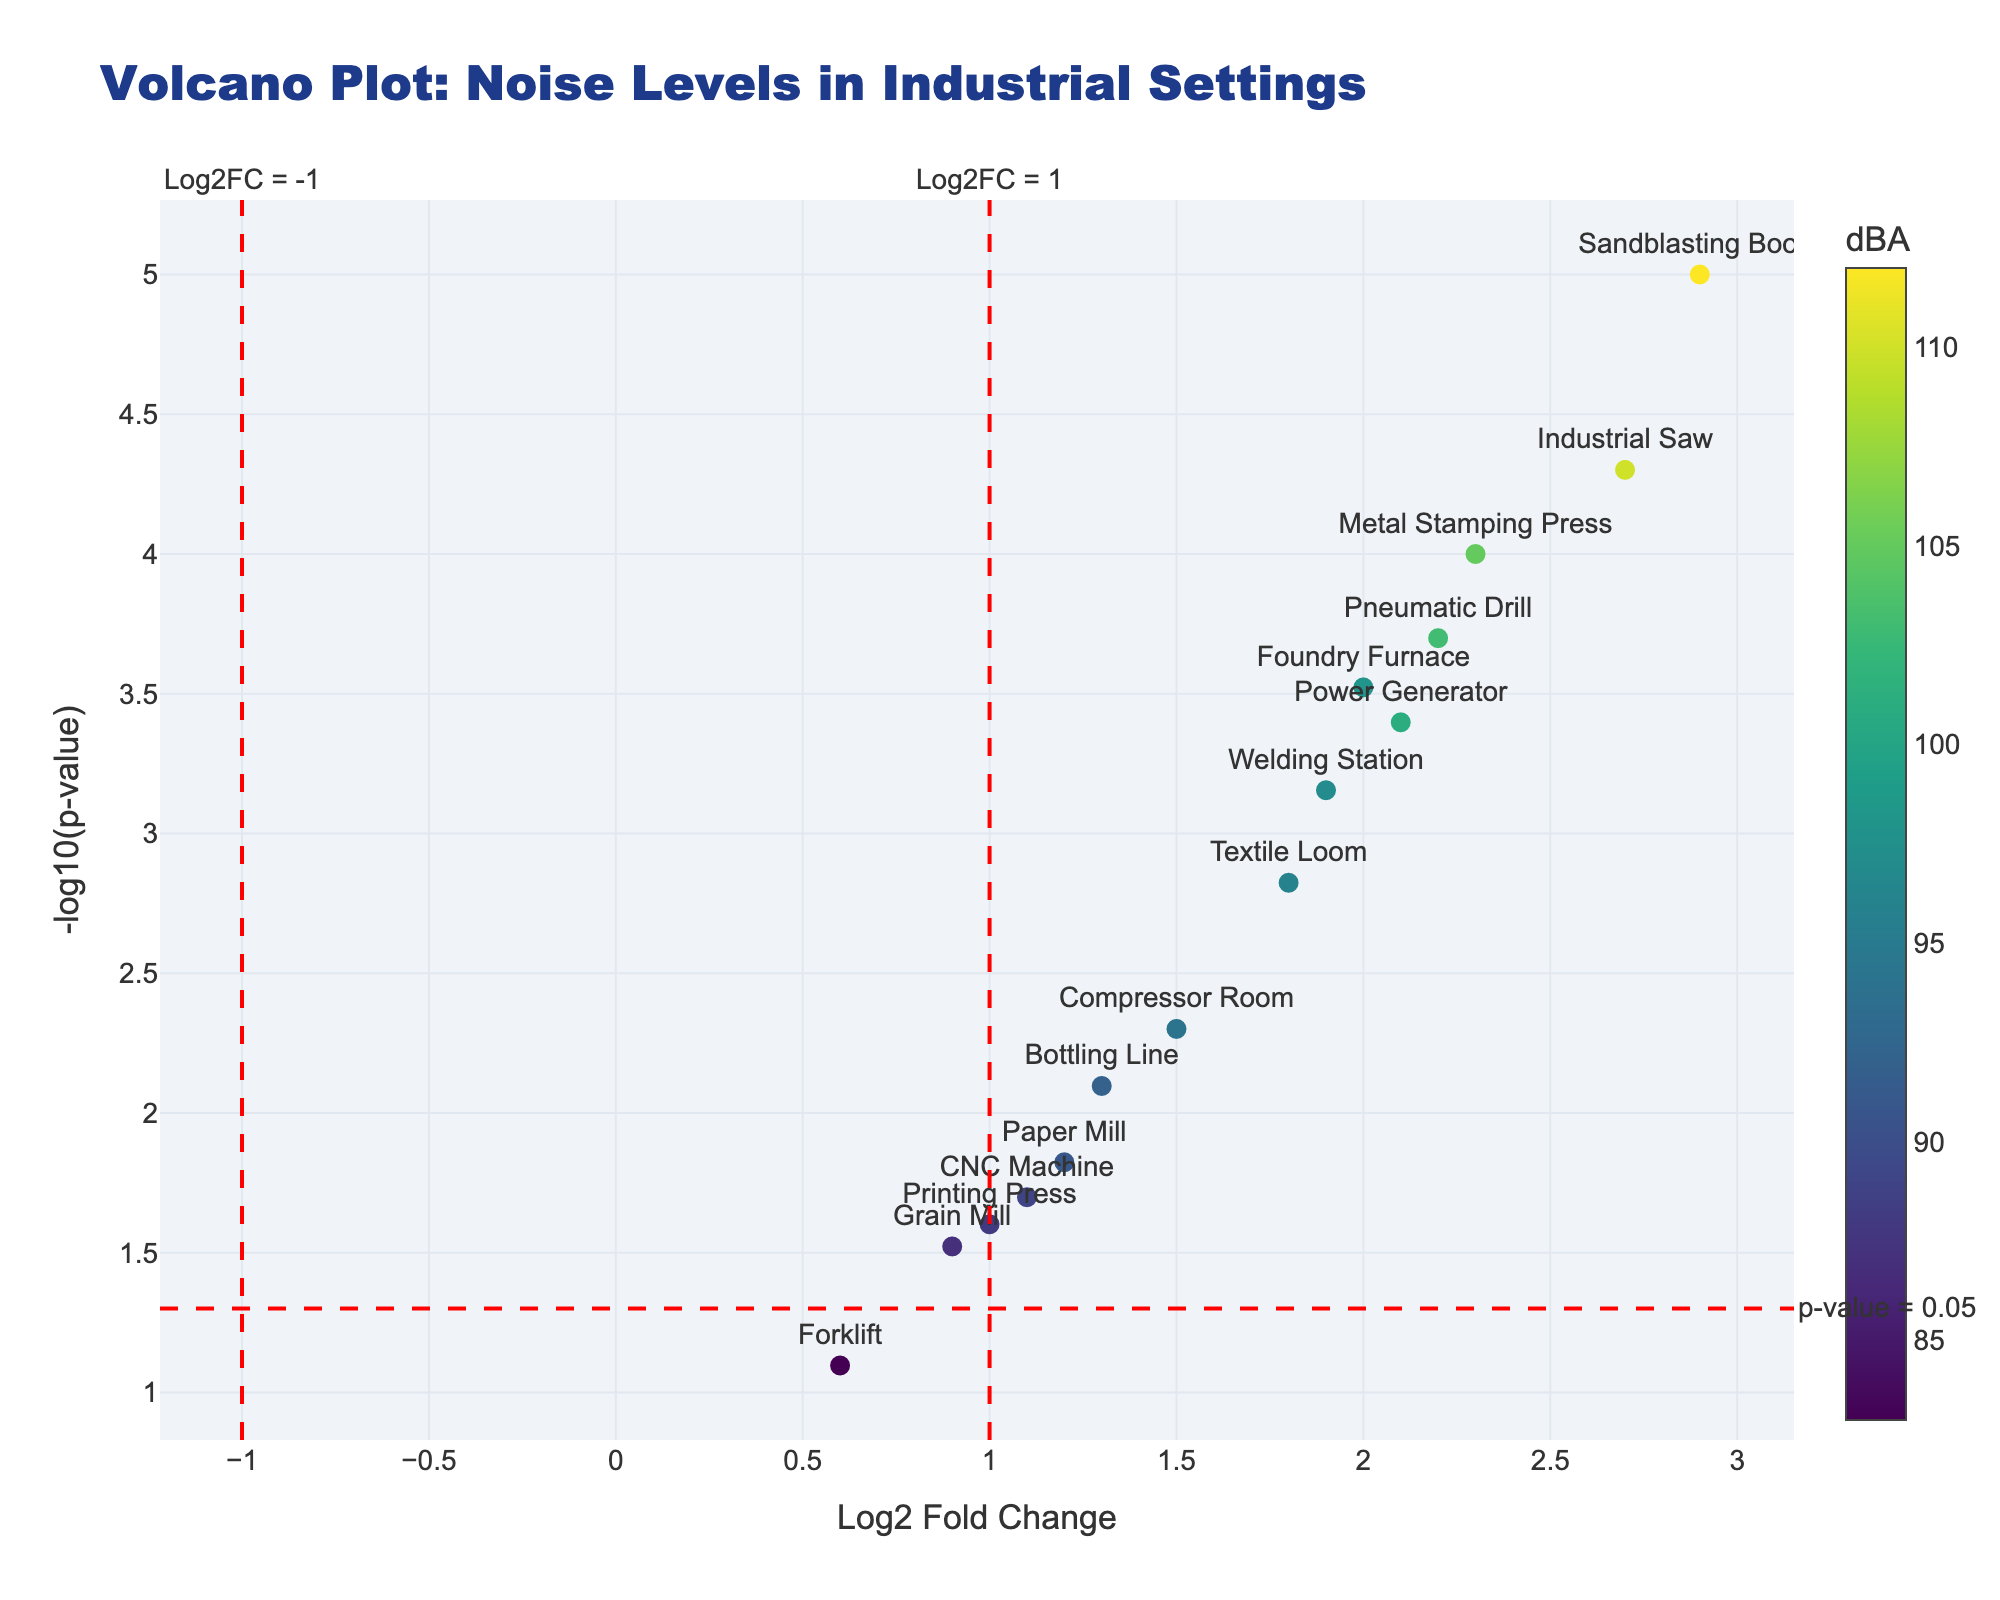Which machine shows the highest -log10(p-value)? The machine with the highest value on the y-axis represents the highest -log10(p-value). In the plot, the "Sandblasting Booth" is the highest.
Answer: Sandblasting Booth What does the color scale represent in the plot? The colors of the markers correspond to the dBA levels of each machine, with a specific color gradient shown in the color bar on the right side of the plot.
Answer: dBA levels Which machines are significantly above the p-value threshold line? The p-value threshold line is set at -log10(0.05). Machines above this line have more significant p-values. These include "Metal Stamping Press," "Industrial Saw," "Foundry Furnace," "Pneumatic Drill," "Welding Station," "Power Generator," and "Sandblasting Booth."
Answer: Metal Stamping Press, Industrial Saw, Foundry Furnace, Pneumatic Drill, Welding Station, Power Generator, Sandblasting Booth What is the Log2 Fold Change threshold set at? There are vertical dashed lines on the plot indicating the Log2 Fold Change thresholds. These lines are set at 1 and -1.
Answer: 1 and -1 Which machine has the log2 Fold Change closest to 0 but is still above the p-value threshold? Machines that meet this criterion should have a Log2 Fold Change near 0 but have a -log10(p-value) above the red threshold line. "Grain Mill" has a Log2 Fold Change of 0.9, which is closest to 0 among the significant points.
Answer: Grain Mill Which machine has the highest dBA and also has a significant p-value? The machine with the highest dBA should also lie above the p-value threshold line. The "Sandblasting Booth" has the highest dBA of 112 while having a significant p-value.
Answer: Sandblasting Booth Compare the Log2 Fold Change values of the "Textile Loom" and "Paper Mill." Which is higher? Looking at the x-axis values for both machines, "Textile Loom" has a Log2 Fold Change of 1.8, and "Paper Mill" has a Log2 Fold Change of 1.2. Therefore, the Log2 Fold Change value for the "Textile Loom" is higher.
Answer: Textile Loom Calculate the mean dBA levels of machines with significant p-values. First, identify machines above the p-value threshold. These machines and their dBA values are: "Metal Stamping Press" (105), "Industrial Saw" (110), "Foundry Furnace" (98), "Pneumatic Drill" (103), "Welding Station" (97), "Power Generator" (101), and "Sandblasting Booth" (112). Their mean dBA is (105 + 110 + 98 + 103 + 97 + 101 + 112)/7 = 103.71
Answer: 103.71 